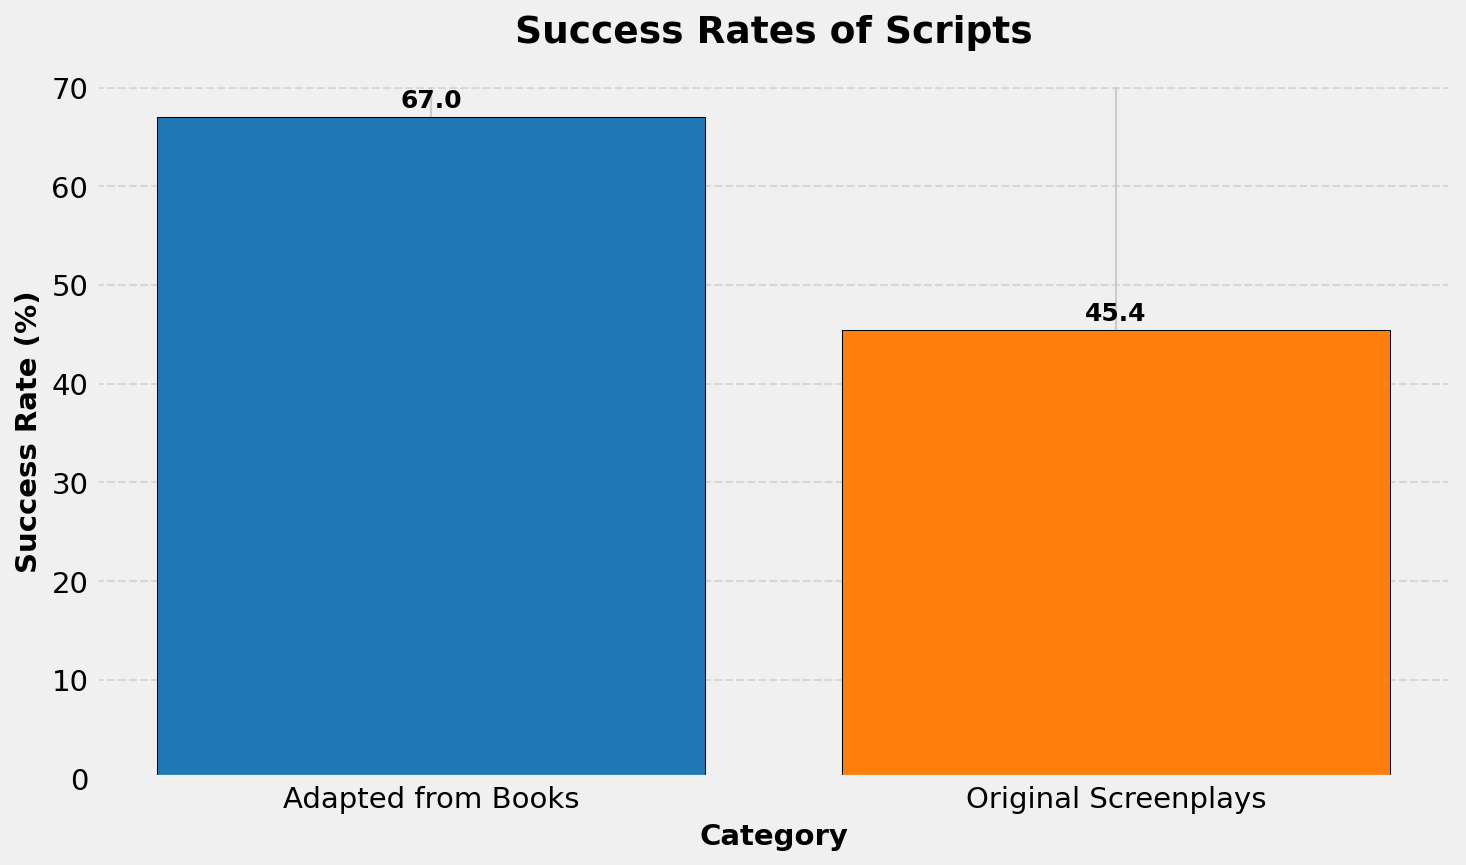Which category has the higher average success rate? The figure shows two categories: "Adapted from Books" and "Original Screenplays." By comparing the heights of the bars, it is evident that "Adapted from Books" has a higher average success rate.
Answer: Adapted from Books What is the average success rate for Original Screenplays? The bar for Original Screenplays is labeled with the success rate. The average success rate is shown as the height of the bar, which is 45.4%.
Answer: 45.4% What is the range of success rates for Adapted from Books? To find the range, we need the minimum and maximum success rates of Adapted from Books (67%, 72%, 61%, 70%, 65%). The range is the difference between the maximum and minimum values: 72 - 61 = 11%.
Answer: 11% How much higher is the average success rate for Adapted from Books compared to Original Screenplays? The average success rate for Adapted from Books is 67%. The average success rate for Original Screenplays is 45.4%. The difference is 67 - 45.4 = 21.6%.
Answer: 21.6% Which bar is taller, and what does it signify? The taller bar represents the category with the higher average success rate. The bar for "Adapted from Books" is taller than for "Original Screenplays," indicating that Adapted scripts have a higher success rate.
Answer: Adapted from Books What is the success rate for the lowest data point in Original Screenplays? By reviewing the individual success rates provided: 45%, 50%, 42%, 47%, 43%, the lowest rate is 42%.
Answer: 42% What is the combined success rate of the highest data points in both categories? The highest success rate for Adapted from Books is 72%, and for Original Screenplays, it’s 50%. Adding them together, 72 + 50 = 122%.
Answer: 122% What's the difference between the highest and lowest success rates among Original Screenplays? The highest success rate for Original Screenplays is 50%, and the lowest is 42%. The difference is 50 - 42 = 8%.
Answer: 8% 